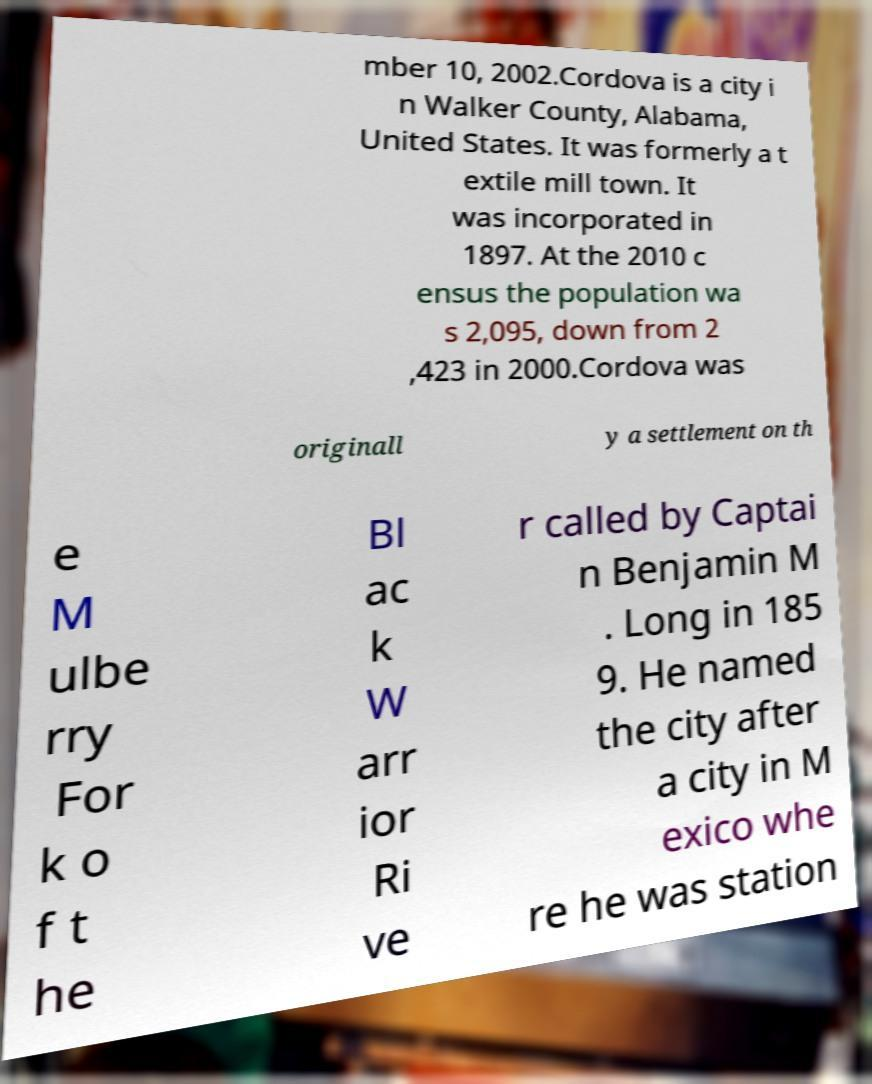Could you extract and type out the text from this image? mber 10, 2002.Cordova is a city i n Walker County, Alabama, United States. It was formerly a t extile mill town. It was incorporated in 1897. At the 2010 c ensus the population wa s 2,095, down from 2 ,423 in 2000.Cordova was originall y a settlement on th e M ulbe rry For k o f t he Bl ac k W arr ior Ri ve r called by Captai n Benjamin M . Long in 185 9. He named the city after a city in M exico whe re he was station 